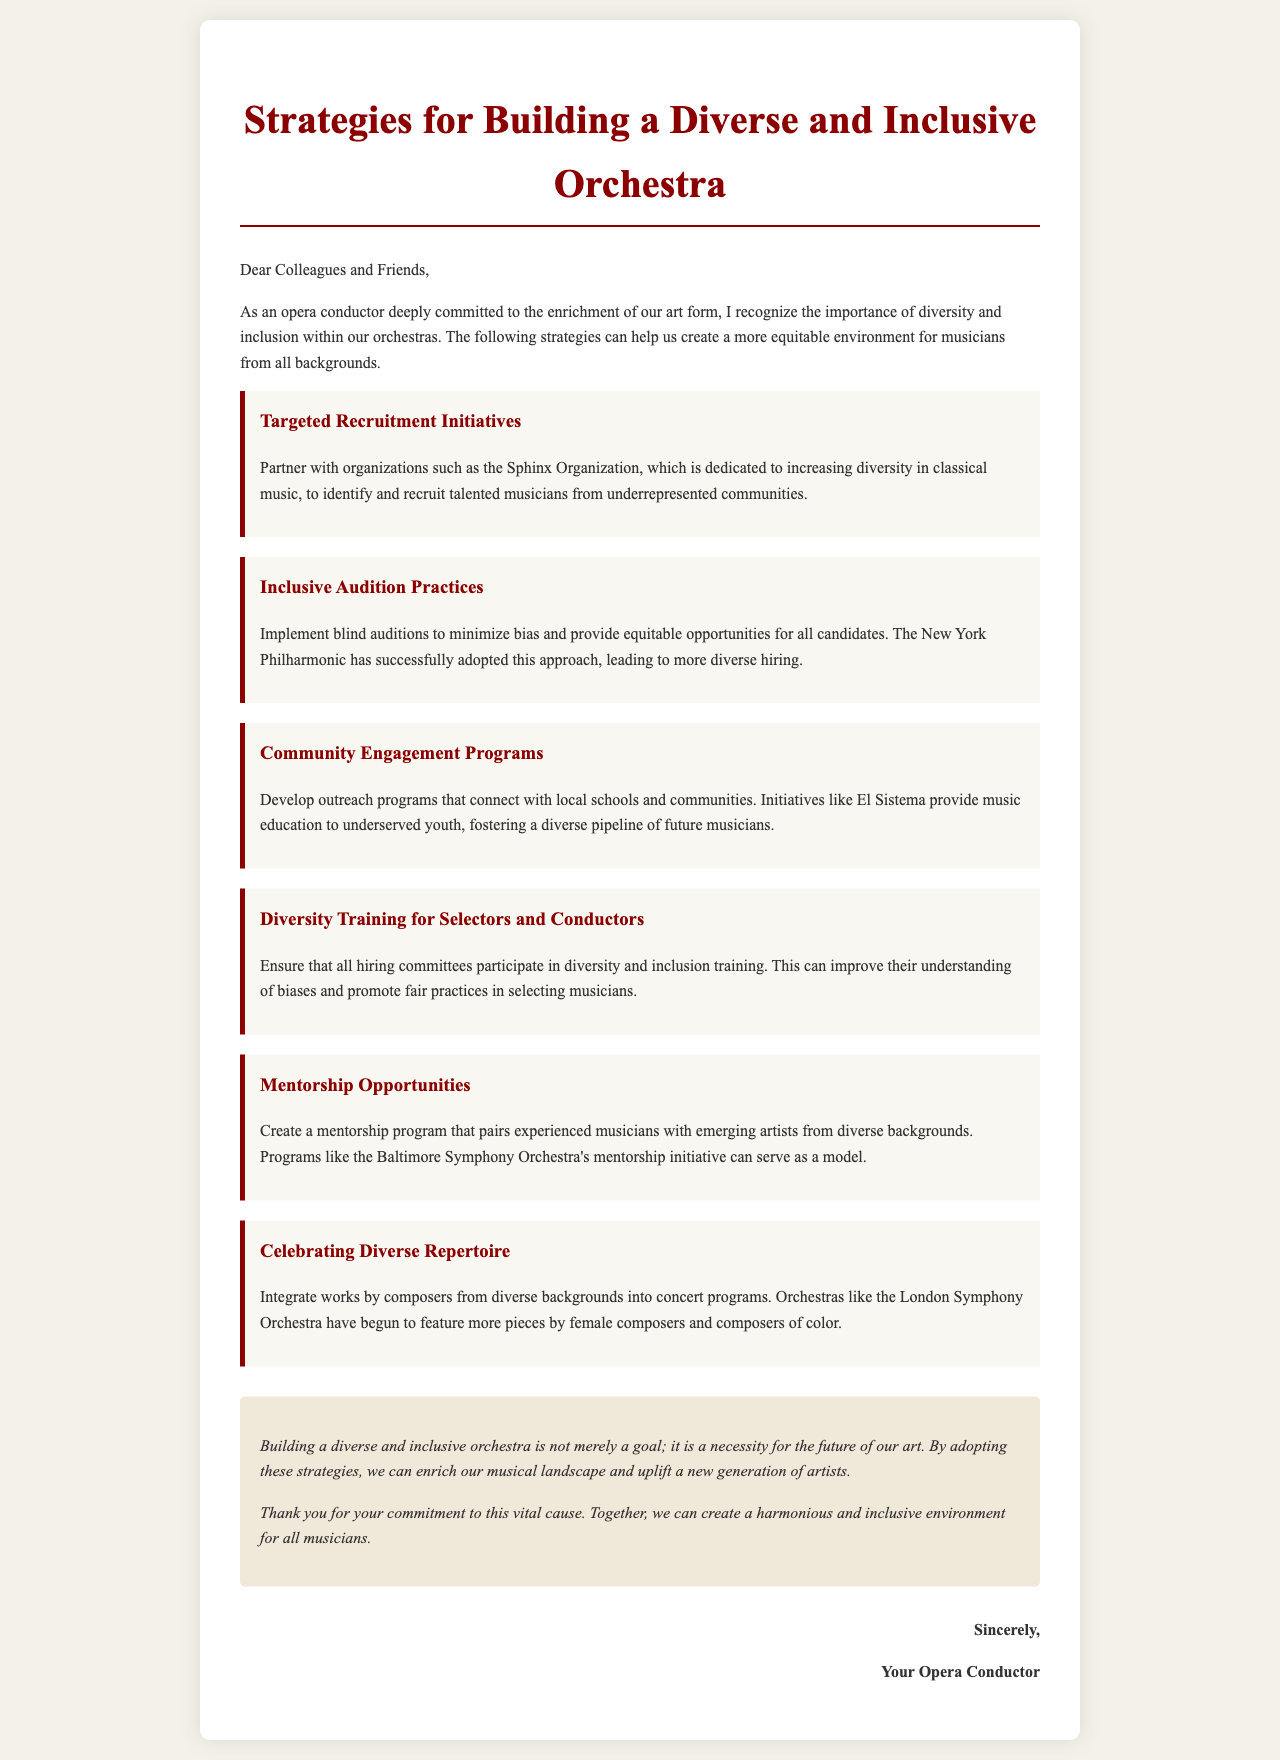What is the title of the document? The title is presented prominently at the top of the document.
Answer: Strategies for Building a Diverse and Inclusive Orchestra Who is the intended audience for this letter? The salutation at the beginning indicates to whom the letter is addressed.
Answer: Colleagues and Friends What is the first strategy mentioned in the document? The strategies are listed in the document, with the first one clearly labeled.
Answer: Targeted Recruitment Initiatives Which organization is mentioned as a partner for recruitment initiatives? The letter specifies a particular organization aimed at enhancing diversity in classical music.
Answer: Sphinx Organization What does the document suggest to minimize bias during auditions? The letter addresses specific practices to ensure fairness in auditions.
Answer: Blind auditions Name one community engagement program mentioned in the document. The letter outlines outreach initiatives to foster community connections.
Answer: El Sistema What is emphasized as a necessary practice for hiring committees? The document highlights an important aspect of preparation for those involved in hiring.
Answer: Diversity and inclusion training What is the last statement in the conclusion section about the future of the art? The conclusion summarizes the overall goal of diversity and inclusion stated in the letter.
Answer: A necessity for the future of our art Who authored the letter? The signature section identifies the individual who wrote the letter.
Answer: Your Opera Conductor 